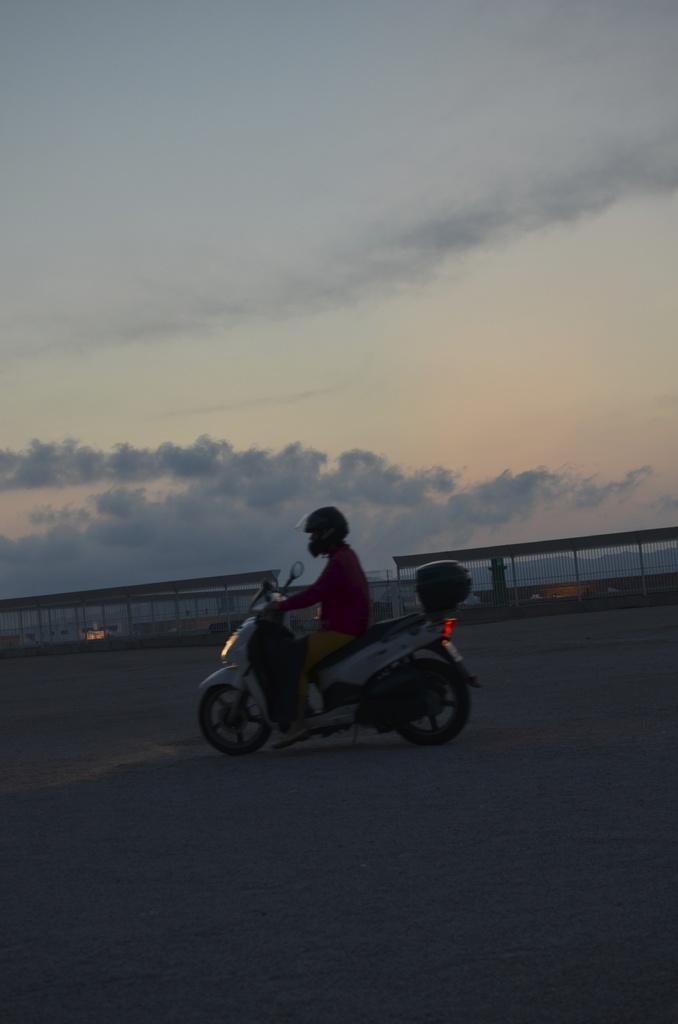Who is present in the image? There is a man in the image. What is the man wearing? The man is wearing a red t-shirt and brown pants. What is the man doing in the image? The man is riding a scooter. Where is the scooter located? The scooter is on the road. What can be seen in the background of the image? There is fencing railing in the background of the image. How is the weather in the image? The sky is clear and blue in the image. What type of stew is the man eating while riding the scooter in the image? There is no stew present in the image, and the man is not eating anything while riding the scooter. 